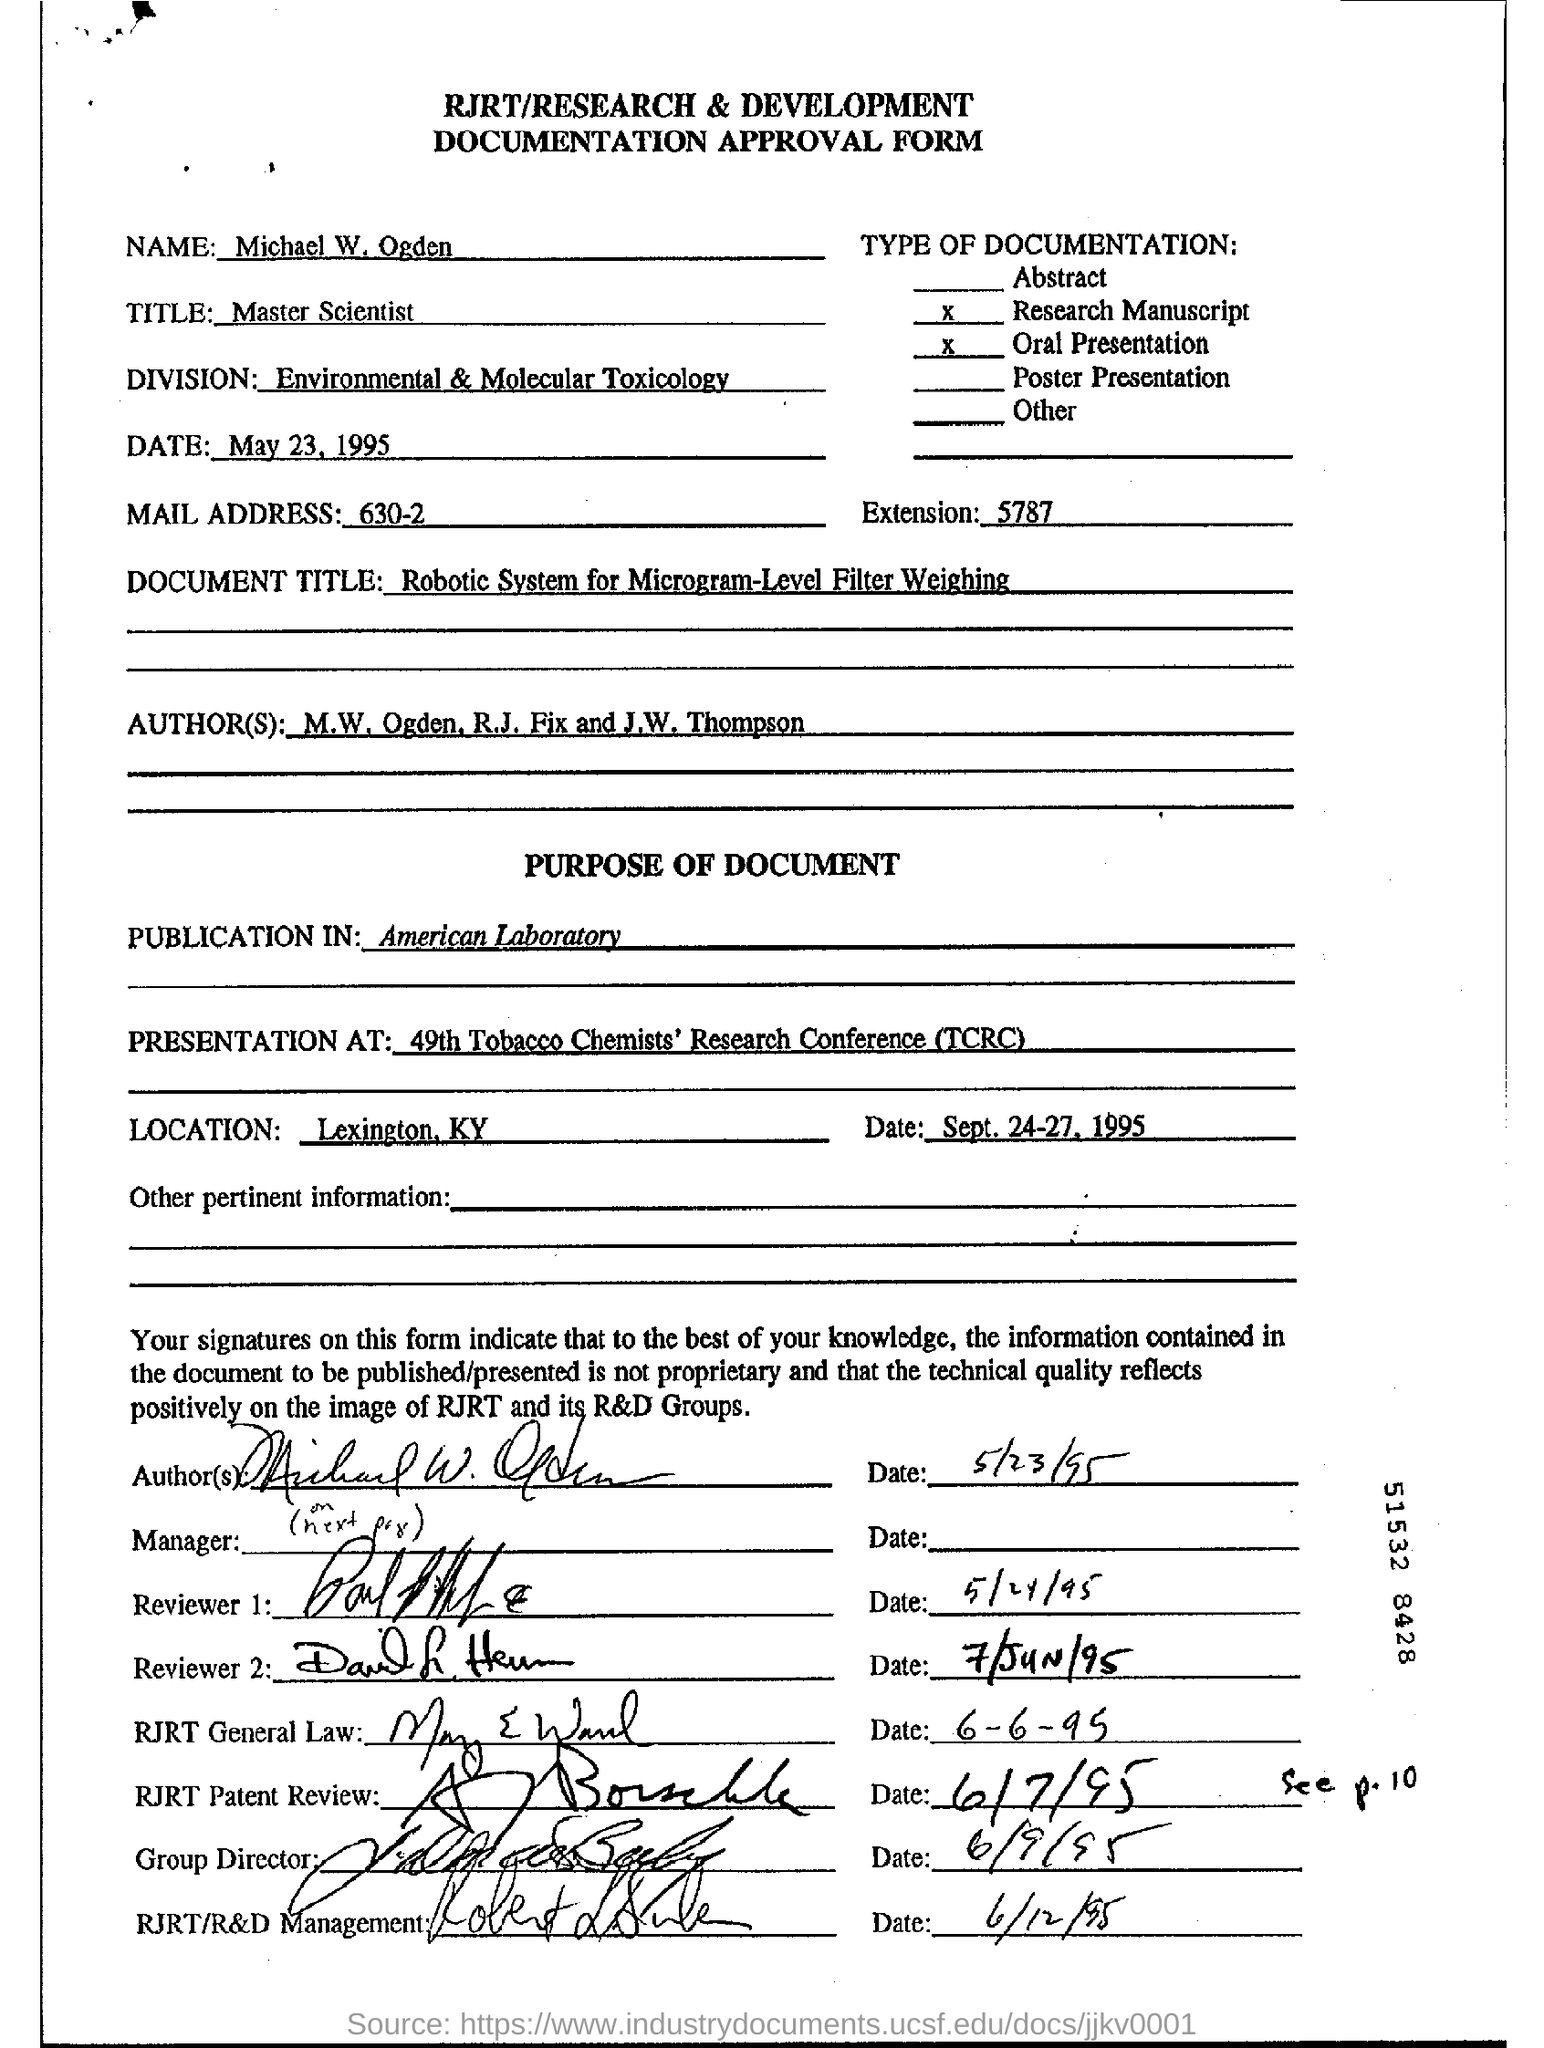Give some essential details in this illustration. The acronym TCRC stands for Tobacco Chemists' Research Conference. Michael W. Ogden holds the job title of Master Scientist. The location of the 49th TCRC is Lexington, Kentucky. The authors of the paper are M.W. Ogden, R.J. Fix, and J.W. Thompson. Michael W. Ogden is a member of the Environmental & Molecular Toxicology division. 